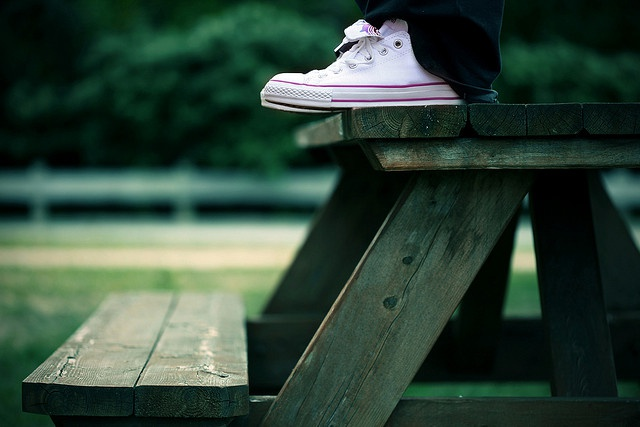Describe the objects in this image and their specific colors. I can see bench in black, darkgreen, and darkgray tones and people in black, lavender, and darkgray tones in this image. 